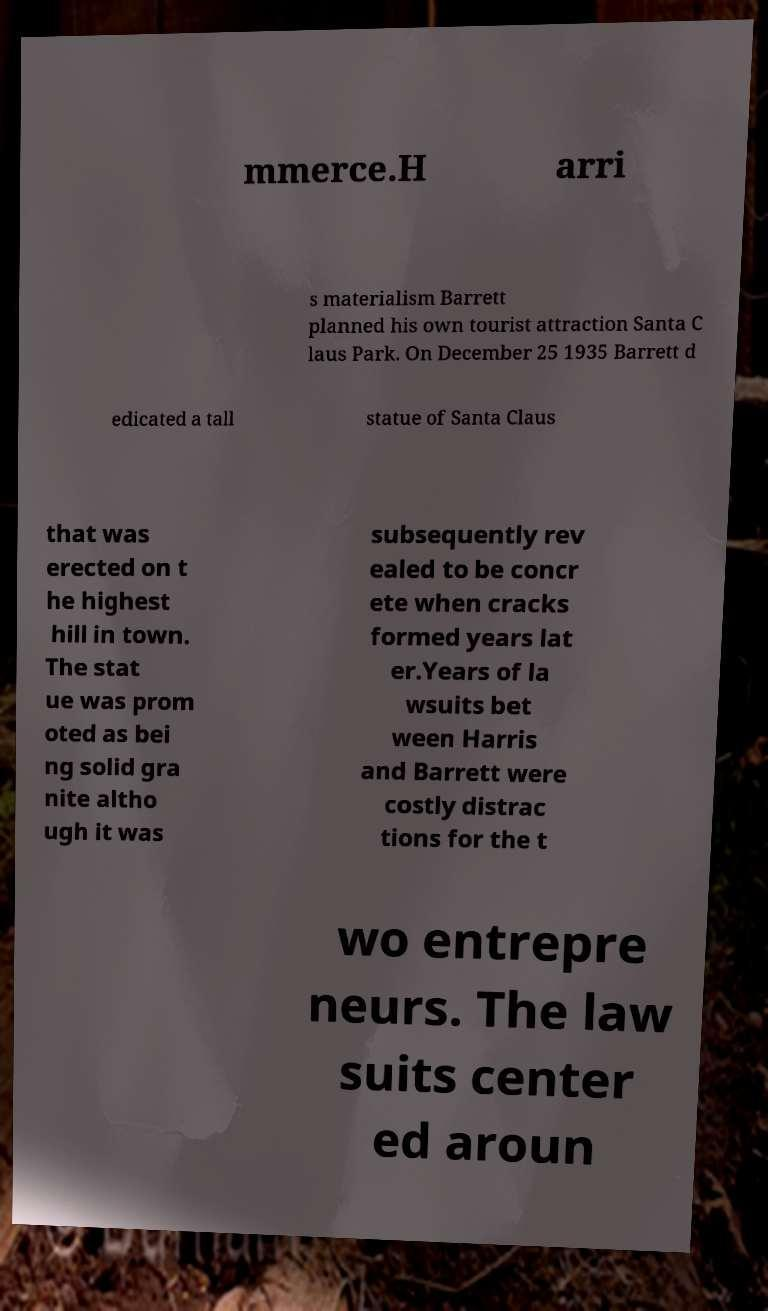Please read and relay the text visible in this image. What does it say? mmerce.H arri s materialism Barrett planned his own tourist attraction Santa C laus Park. On December 25 1935 Barrett d edicated a tall statue of Santa Claus that was erected on t he highest hill in town. The stat ue was prom oted as bei ng solid gra nite altho ugh it was subsequently rev ealed to be concr ete when cracks formed years lat er.Years of la wsuits bet ween Harris and Barrett were costly distrac tions for the t wo entrepre neurs. The law suits center ed aroun 